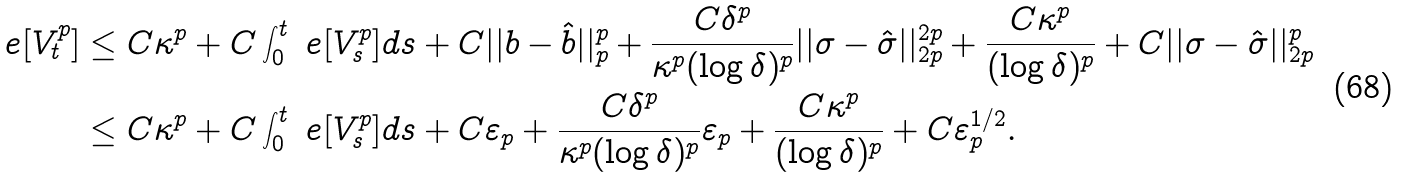<formula> <loc_0><loc_0><loc_500><loc_500>\ e [ V _ { t } ^ { p } ] & \leq C \kappa ^ { p } + C \int _ { 0 } ^ { t } \ e [ V _ { s } ^ { p } ] d s + C | | b - \hat { b } | | _ { p } ^ { p } + \frac { C \delta ^ { p } } { \kappa ^ { p } ( \log \delta ) ^ { p } } | | \sigma - \hat { \sigma } | | _ { 2 p } ^ { 2 p } + \frac { C \kappa ^ { p } } { ( \log \delta ) ^ { p } } + C | | \sigma - \hat { \sigma } | | _ { 2 p } ^ { p } \\ & \leq C \kappa ^ { p } + C \int _ { 0 } ^ { t } \ e [ V _ { s } ^ { p } ] d s + C \varepsilon _ { p } + \frac { C \delta ^ { p } } { \kappa ^ { p } ( \log \delta ) ^ { p } } \varepsilon _ { p } + \frac { C \kappa ^ { p } } { ( \log \delta ) ^ { p } } + C \varepsilon _ { p } ^ { 1 / 2 } .</formula> 